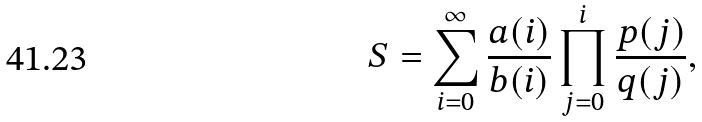<formula> <loc_0><loc_0><loc_500><loc_500>S = \sum _ { i = 0 } ^ { \infty } { \frac { a ( i ) } { b ( i ) } \prod _ { j = 0 } ^ { i } { \frac { p ( j ) } { q ( j ) } } } ,</formula> 